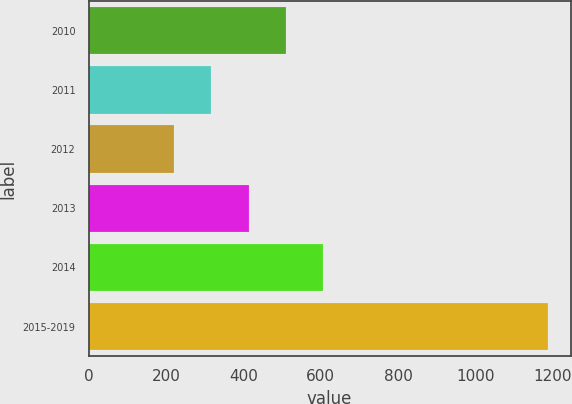<chart> <loc_0><loc_0><loc_500><loc_500><bar_chart><fcel>2010<fcel>2011<fcel>2012<fcel>2013<fcel>2014<fcel>2015-2019<nl><fcel>510.8<fcel>317.6<fcel>221<fcel>414.2<fcel>607.4<fcel>1187<nl></chart> 